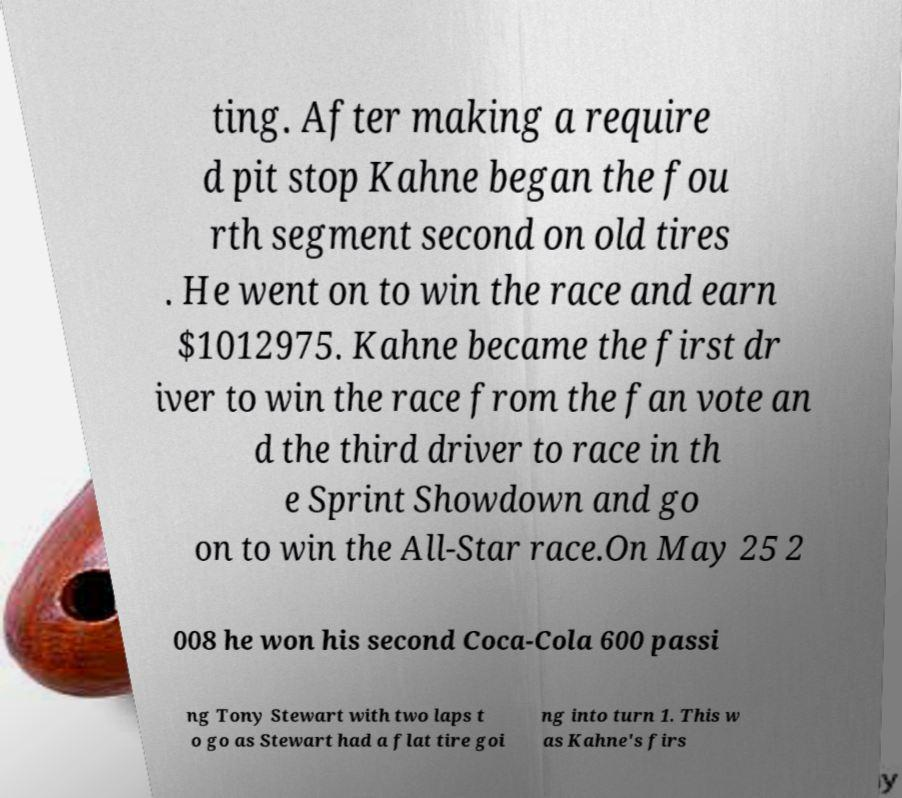Please read and relay the text visible in this image. What does it say? ting. After making a require d pit stop Kahne began the fou rth segment second on old tires . He went on to win the race and earn $1012975. Kahne became the first dr iver to win the race from the fan vote an d the third driver to race in th e Sprint Showdown and go on to win the All-Star race.On May 25 2 008 he won his second Coca-Cola 600 passi ng Tony Stewart with two laps t o go as Stewart had a flat tire goi ng into turn 1. This w as Kahne's firs 